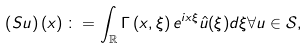Convert formula to latex. <formula><loc_0><loc_0><loc_500><loc_500>\left ( S u \right ) \left ( x \right ) \colon = \int _ { \mathbb { R } } \Gamma \left ( x , \xi \right ) e ^ { i x \xi } \hat { u } ( \xi ) d \xi \forall u \in \mathcal { S } ,</formula> 